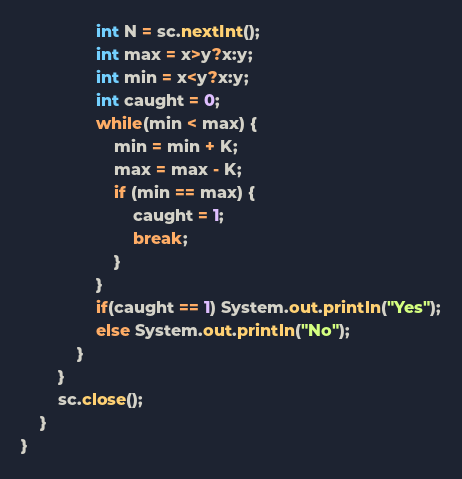Convert code to text. <code><loc_0><loc_0><loc_500><loc_500><_Java_>                int N = sc.nextInt();
                int max = x>y?x:y;
                int min = x<y?x:y;
                int caught = 0;
                while(min < max) {
                    min = min + K;
                    max = max - K;
                    if (min == max) {
                        caught = 1;
                        break;
                    }
                }
                if(caught == 1) System.out.println("Yes");
                else System.out.println("No");
            }
        }
        sc.close();
    }
}
</code> 